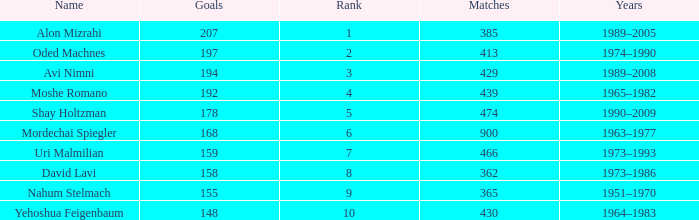What is the Rank of the player with 158 Goals in more than 362 Matches? 0.0. 